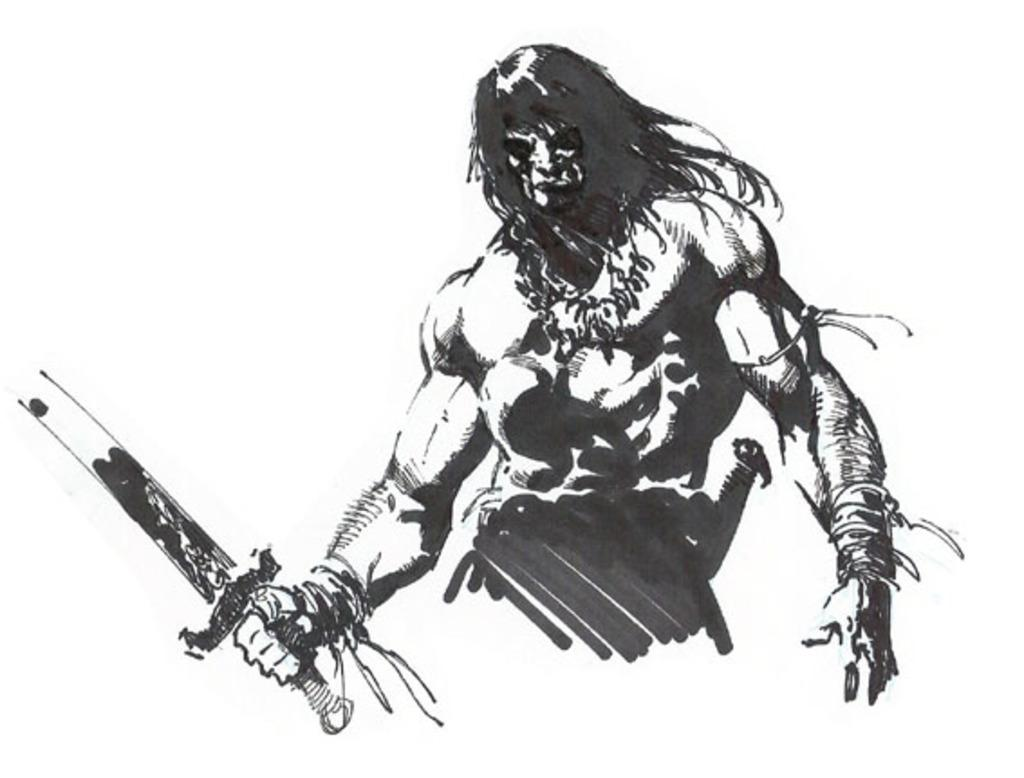What type of picture is present in the image? The image contains an animated picture. What subject is the teacher teaching in the image? There is no teacher or teaching activity present in the image; it contains an animated picture. What type of flight is depicted in the image? There is no flight or any reference to aviation in the image; it contains an animated picture. 